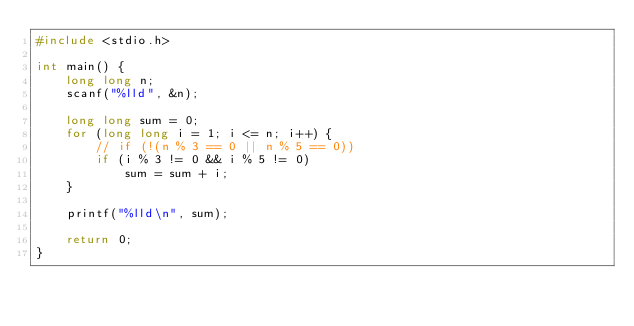Convert code to text. <code><loc_0><loc_0><loc_500><loc_500><_C_>#include <stdio.h>

int main() {
    long long n;
    scanf("%lld", &n);

    long long sum = 0;
    for (long long i = 1; i <= n; i++) {
        // if (!(n % 3 == 0 || n % 5 == 0))
        if (i % 3 != 0 && i % 5 != 0)
            sum = sum + i;
    }

    printf("%lld\n", sum);

    return 0;
}</code> 